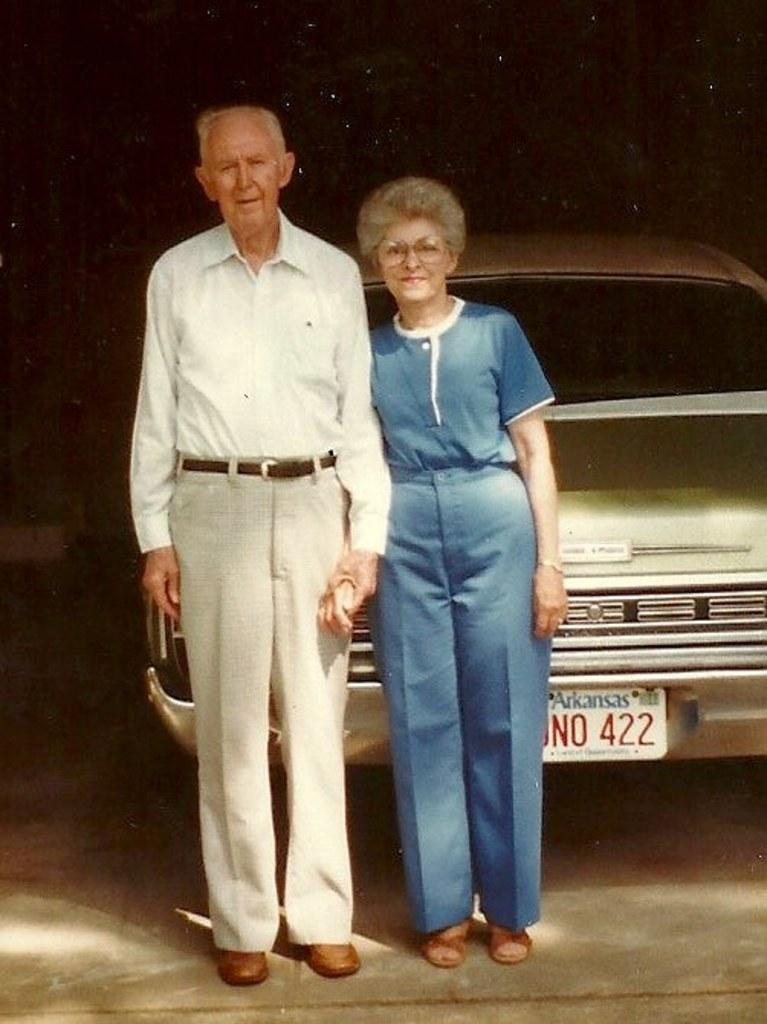How many people are in the image? There are two people in the image. What is on the ground in the image? There is a vehicle on the ground in the image. What can be observed about the background of the image? The background of the image is dark. What type of mint is growing near the vehicle in the image? There is no mint present in the image. How many rolls can be seen in the hands of the people in the image? There is no indication of any rolls in the image; the people are not holding anything. 